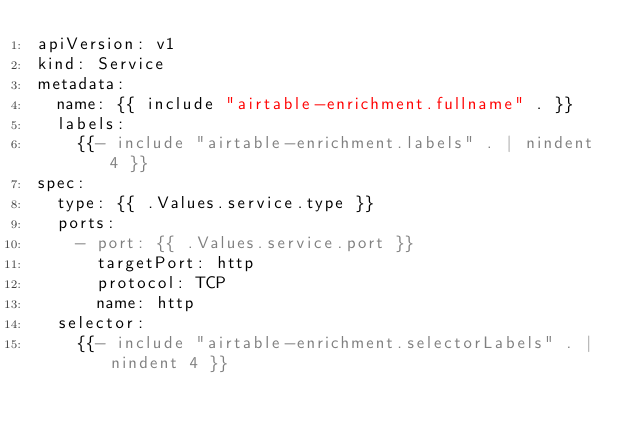Convert code to text. <code><loc_0><loc_0><loc_500><loc_500><_YAML_>apiVersion: v1
kind: Service
metadata:
  name: {{ include "airtable-enrichment.fullname" . }}
  labels:
    {{- include "airtable-enrichment.labels" . | nindent 4 }}
spec:
  type: {{ .Values.service.type }}
  ports:
    - port: {{ .Values.service.port }}
      targetPort: http
      protocol: TCP
      name: http
  selector:
    {{- include "airtable-enrichment.selectorLabels" . | nindent 4 }}
</code> 